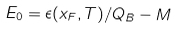Convert formula to latex. <formula><loc_0><loc_0><loc_500><loc_500>E _ { 0 } = \epsilon ( x _ { F } , T ) / Q _ { B } - M</formula> 